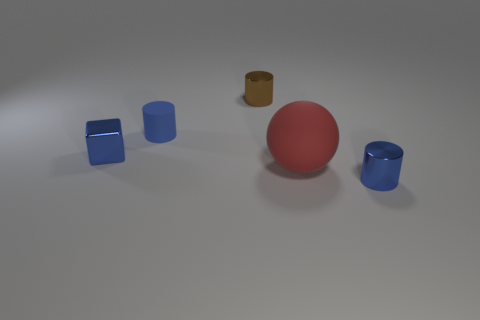Subtract all purple blocks. How many blue cylinders are left? 2 Subtract all tiny brown cylinders. How many cylinders are left? 2 Add 2 red objects. How many objects exist? 7 Subtract all cylinders. How many objects are left? 2 Subtract all green cylinders. Subtract all brown cubes. How many cylinders are left? 3 Subtract all small brown things. Subtract all small blue metal things. How many objects are left? 2 Add 5 small cubes. How many small cubes are left? 6 Add 3 big red balls. How many big red balls exist? 4 Subtract 1 red balls. How many objects are left? 4 